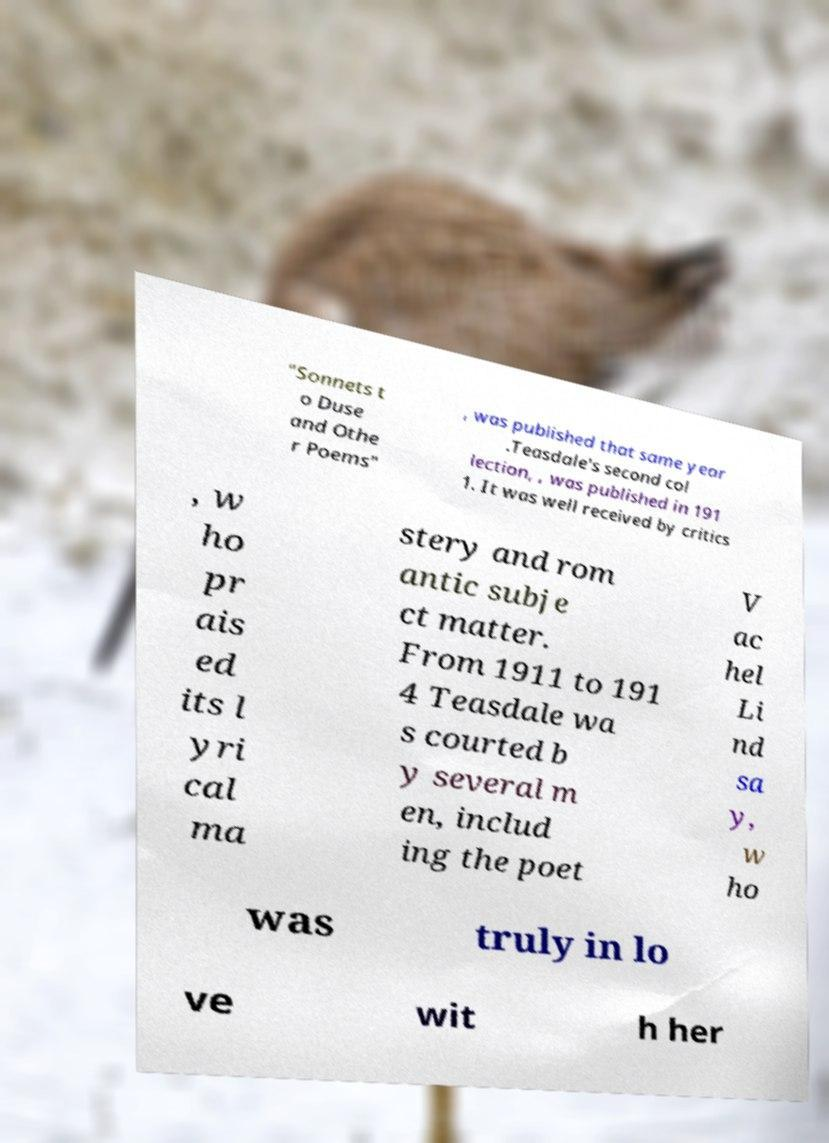Please identify and transcribe the text found in this image. "Sonnets t o Duse and Othe r Poems" , was published that same year .Teasdale's second col lection, , was published in 191 1. It was well received by critics , w ho pr ais ed its l yri cal ma stery and rom antic subje ct matter. From 1911 to 191 4 Teasdale wa s courted b y several m en, includ ing the poet V ac hel Li nd sa y, w ho was truly in lo ve wit h her 